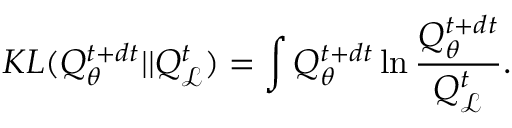<formula> <loc_0><loc_0><loc_500><loc_500>K L ( Q _ { \theta } ^ { t + d t } | | Q _ { \mathcal { L } } ^ { t } ) = \int Q _ { \theta } ^ { t + d t } \ln \frac { Q _ { \theta } ^ { t + d t } } { Q _ { \mathcal { L } } ^ { t } } .</formula> 